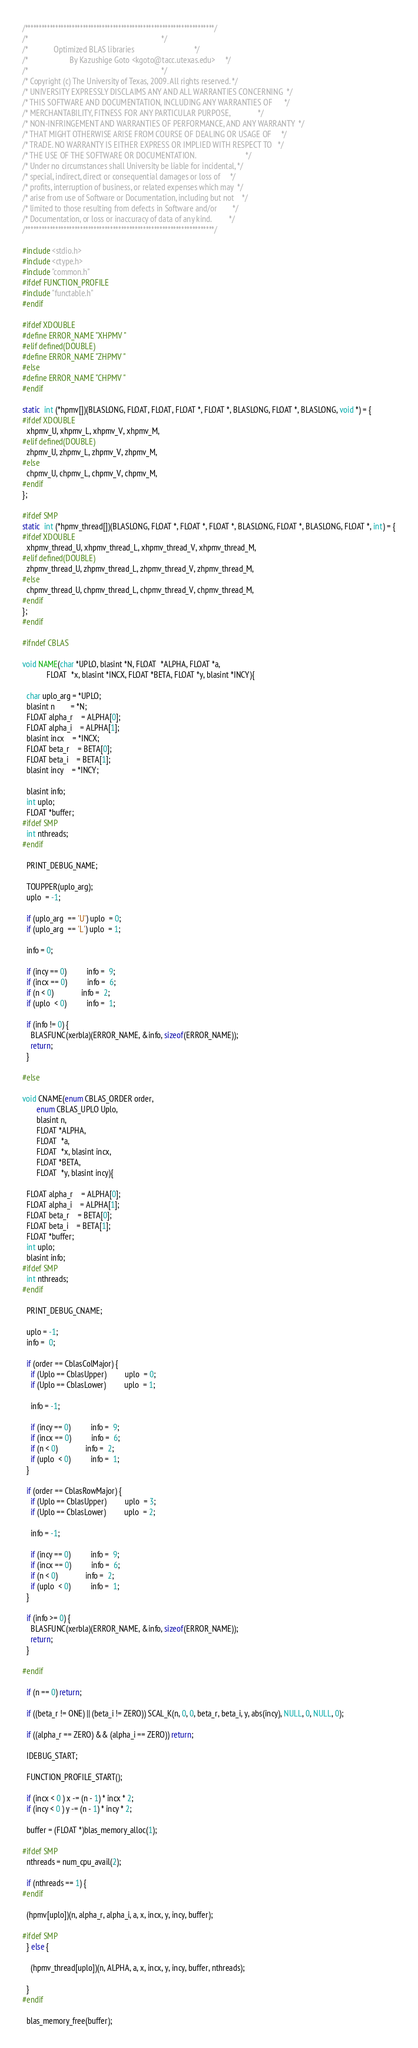Convert code to text. <code><loc_0><loc_0><loc_500><loc_500><_C_>/*********************************************************************/
/*                                                                   */
/*             Optimized BLAS libraries                              */
/*                     By Kazushige Goto <kgoto@tacc.utexas.edu>     */
/*                                                                   */
/* Copyright (c) The University of Texas, 2009. All rights reserved. */
/* UNIVERSITY EXPRESSLY DISCLAIMS ANY AND ALL WARRANTIES CONCERNING  */
/* THIS SOFTWARE AND DOCUMENTATION, INCLUDING ANY WARRANTIES OF      */
/* MERCHANTABILITY, FITNESS FOR ANY PARTICULAR PURPOSE,              */
/* NON-INFRINGEMENT AND WARRANTIES OF PERFORMANCE, AND ANY WARRANTY  */
/* THAT MIGHT OTHERWISE ARISE FROM COURSE OF DEALING OR USAGE OF     */
/* TRADE. NO WARRANTY IS EITHER EXPRESS OR IMPLIED WITH RESPECT TO   */
/* THE USE OF THE SOFTWARE OR DOCUMENTATION.                         */
/* Under no circumstances shall University be liable for incidental, */
/* special, indirect, direct or consequential damages or loss of     */
/* profits, interruption of business, or related expenses which may  */
/* arise from use of Software or Documentation, including but not    */
/* limited to those resulting from defects in Software and/or        */
/* Documentation, or loss or inaccuracy of data of any kind.         */
/*********************************************************************/

#include <stdio.h>
#include <ctype.h>
#include "common.h"
#ifdef FUNCTION_PROFILE
#include "functable.h"
#endif

#ifdef XDOUBLE
#define ERROR_NAME "XHPMV "
#elif defined(DOUBLE)
#define ERROR_NAME "ZHPMV "
#else
#define ERROR_NAME "CHPMV "
#endif

static  int (*hpmv[])(BLASLONG, FLOAT, FLOAT, FLOAT *, FLOAT *, BLASLONG, FLOAT *, BLASLONG, void *) = {
#ifdef XDOUBLE
  xhpmv_U, xhpmv_L, xhpmv_V, xhpmv_M,
#elif defined(DOUBLE)
  zhpmv_U, zhpmv_L, zhpmv_V, zhpmv_M,
#else
  chpmv_U, chpmv_L, chpmv_V, chpmv_M,
#endif
};

#ifdef SMP
static  int (*hpmv_thread[])(BLASLONG, FLOAT *, FLOAT *, FLOAT *, BLASLONG, FLOAT *, BLASLONG, FLOAT *, int) = {
#ifdef XDOUBLE
  xhpmv_thread_U, xhpmv_thread_L, xhpmv_thread_V, xhpmv_thread_M,
#elif defined(DOUBLE)
  zhpmv_thread_U, zhpmv_thread_L, zhpmv_thread_V, zhpmv_thread_M,
#else
  chpmv_thread_U, chpmv_thread_L, chpmv_thread_V, chpmv_thread_M,
#endif
};
#endif

#ifndef CBLAS

void NAME(char *UPLO, blasint *N, FLOAT  *ALPHA, FLOAT *a,
            FLOAT  *x, blasint *INCX, FLOAT *BETA, FLOAT *y, blasint *INCY){

  char uplo_arg = *UPLO;
  blasint n		= *N;
  FLOAT alpha_r	= ALPHA[0];
  FLOAT alpha_i	= ALPHA[1];
  blasint incx	= *INCX;
  FLOAT beta_r	= BETA[0];
  FLOAT beta_i	= BETA[1];
  blasint incy	= *INCY;

  blasint info;
  int uplo;
  FLOAT *buffer;
#ifdef SMP
  int nthreads;
#endif

  PRINT_DEBUG_NAME;

  TOUPPER(uplo_arg);
  uplo  = -1;

  if (uplo_arg  == 'U') uplo  = 0;
  if (uplo_arg  == 'L') uplo  = 1;
 
  info = 0;

  if (incy == 0)          info =  9;
  if (incx == 0)          info =  6;
  if (n < 0)              info =  2;
  if (uplo  < 0)          info =  1;

  if (info != 0) {
    BLASFUNC(xerbla)(ERROR_NAME, &info, sizeof(ERROR_NAME));
    return;
  }

#else

void CNAME(enum CBLAS_ORDER order,
	   enum CBLAS_UPLO Uplo,
	   blasint n,
	   FLOAT *ALPHA,
	   FLOAT  *a,
	   FLOAT  *x, blasint incx,
	   FLOAT *BETA,
	   FLOAT  *y, blasint incy){

  FLOAT alpha_r	= ALPHA[0];
  FLOAT alpha_i	= ALPHA[1];
  FLOAT beta_r	= BETA[0];
  FLOAT beta_i	= BETA[1];
  FLOAT *buffer;
  int uplo;
  blasint info;
#ifdef SMP
  int nthreads;
#endif

  PRINT_DEBUG_CNAME;

  uplo = -1;
  info =  0;

  if (order == CblasColMajor) {
    if (Uplo == CblasUpper)         uplo  = 0;
    if (Uplo == CblasLower)         uplo  = 1;
    
    info = -1;

    if (incy == 0)          info =  9;
    if (incx == 0)          info =  6;
    if (n < 0)              info =  2;
    if (uplo  < 0)          info =  1;
  }

  if (order == CblasRowMajor) {
    if (Uplo == CblasUpper)         uplo  = 3;
    if (Uplo == CblasLower)         uplo  = 2;

    info = -1;

    if (incy == 0)          info =  9;
    if (incx == 0)          info =  6;
    if (n < 0)              info =  2;
    if (uplo  < 0)          info =  1;
  }

  if (info >= 0) {
    BLASFUNC(xerbla)(ERROR_NAME, &info, sizeof(ERROR_NAME));
    return;
  }

#endif

  if (n == 0) return;

  if ((beta_r != ONE) || (beta_i != ZERO)) SCAL_K(n, 0, 0, beta_r, beta_i, y, abs(incy), NULL, 0, NULL, 0);

  if ((alpha_r == ZERO) && (alpha_i == ZERO)) return;

  IDEBUG_START;

  FUNCTION_PROFILE_START();

  if (incx < 0 ) x -= (n - 1) * incx * 2;
  if (incy < 0 ) y -= (n - 1) * incy * 2;

  buffer = (FLOAT *)blas_memory_alloc(1);

#ifdef SMP
  nthreads = num_cpu_avail(2);

  if (nthreads == 1) {
#endif

  (hpmv[uplo])(n, alpha_r, alpha_i, a, x, incx, y, incy, buffer);

#ifdef SMP
  } else {

    (hpmv_thread[uplo])(n, ALPHA, a, x, incx, y, incy, buffer, nthreads);

  }
#endif

  blas_memory_free(buffer);
</code> 